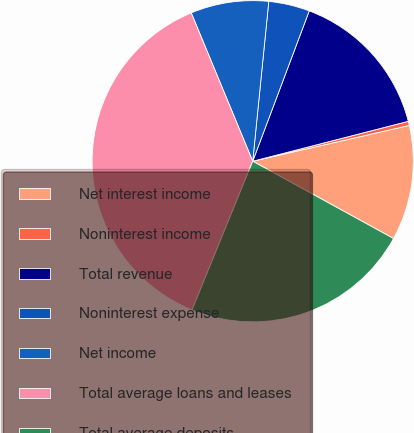<chart> <loc_0><loc_0><loc_500><loc_500><pie_chart><fcel>Net interest income<fcel>Noninterest income<fcel>Total revenue<fcel>Noninterest expense<fcel>Net income<fcel>Total average loans and leases<fcel>Total average deposits<nl><fcel>11.57%<fcel>0.42%<fcel>15.28%<fcel>4.13%<fcel>7.85%<fcel>37.58%<fcel>23.18%<nl></chart> 